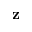Convert formula to latex. <formula><loc_0><loc_0><loc_500><loc_500>z</formula> 